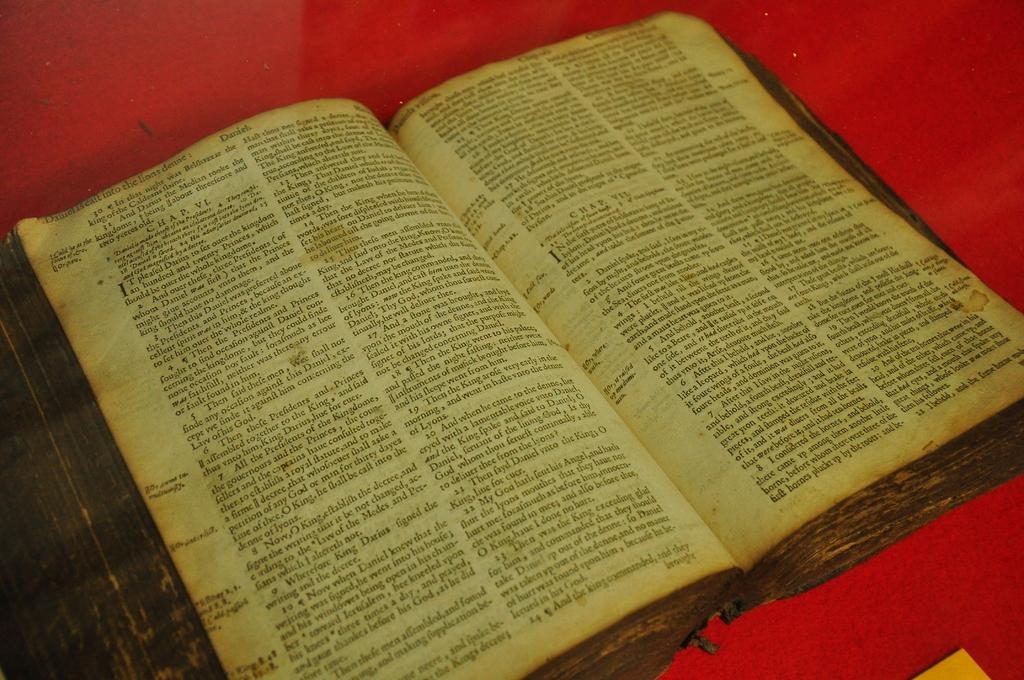<image>
Write a terse but informative summary of the picture. Book open on a page that says "Daniel is caft into the lions denne" near the top. 